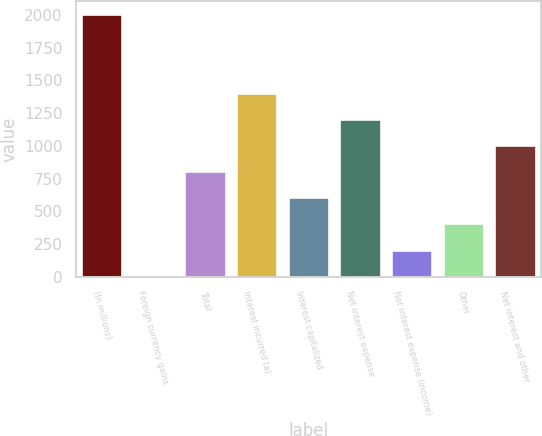<chart> <loc_0><loc_0><loc_500><loc_500><bar_chart><fcel>(In millions)<fcel>Foreign currency gains<fcel>Total<fcel>Interest incurred (a)<fcel>Interest capitalized<fcel>Net interest expense<fcel>Net interest expense (income)<fcel>Other<fcel>Net interest and other<nl><fcel>2004<fcel>9<fcel>807<fcel>1405.5<fcel>607.5<fcel>1206<fcel>208.5<fcel>408<fcel>1006.5<nl></chart> 